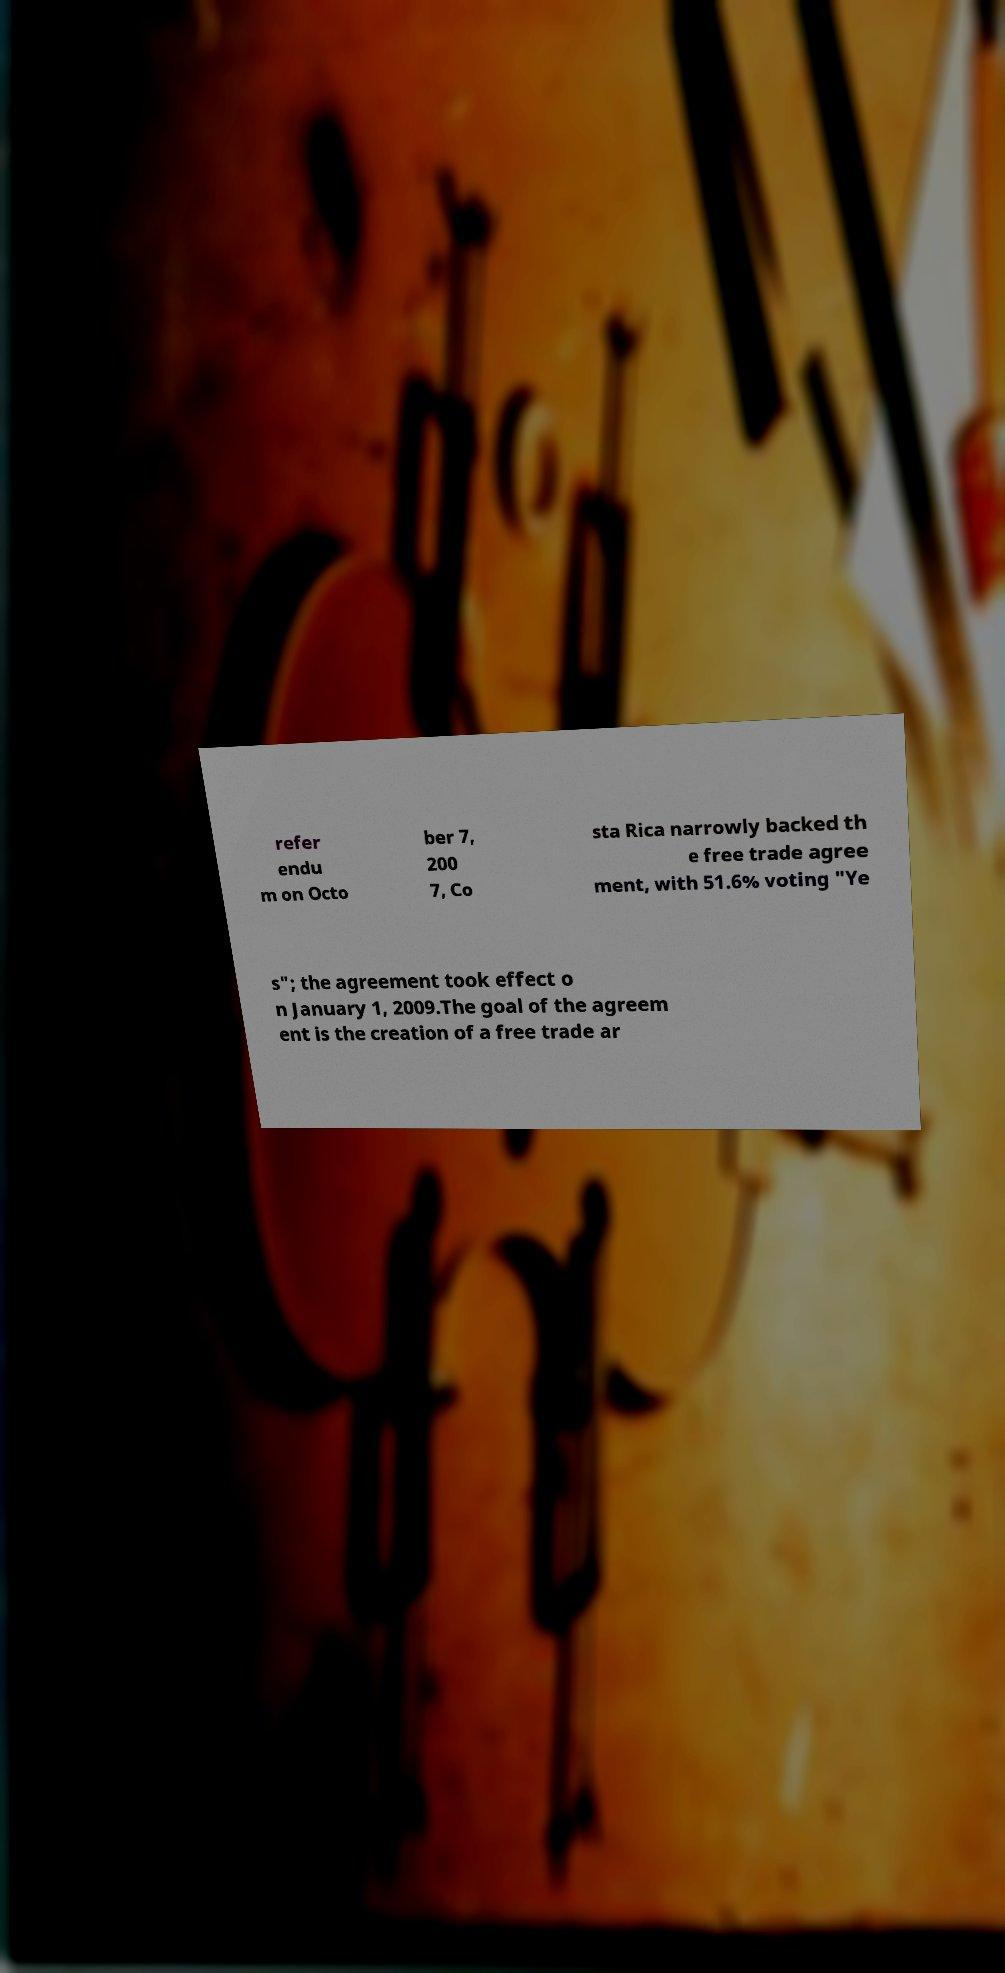For documentation purposes, I need the text within this image transcribed. Could you provide that? refer endu m on Octo ber 7, 200 7, Co sta Rica narrowly backed th e free trade agree ment, with 51.6% voting "Ye s"; the agreement took effect o n January 1, 2009.The goal of the agreem ent is the creation of a free trade ar 